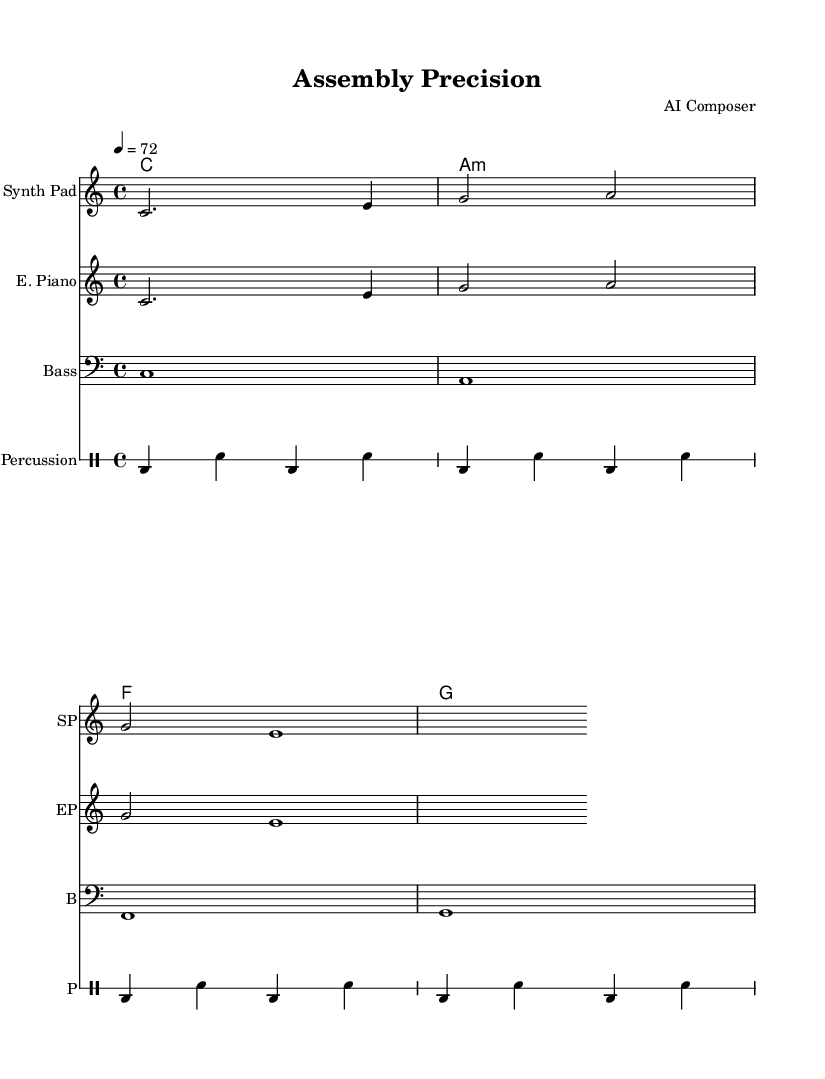What is the key signature of this music? The key signature is C major, which has no sharps or flats.
Answer: C major What is the time signature of this music? The time signature is indicated after the key signature and consists of two numbers, with the top number showing the number of beats in a measure. For this piece, it is 4 over 4, meaning there are four beats per measure.
Answer: 4/4 What is the tempo marking of this music? The tempo marking is shown as a metronome indication at the beginning of the piece, set at 72 BPM, indicating that there are 72 beats played in one minute.
Answer: 72 Which instrument plays the melody? The sheet music indicates the "Synth Pad" and "E. Piano" as instruments. Both have the same melody, so each plays a melodic line. However, the notation shows a designated melody in the staff.
Answer: Synth Pad and E. Piano What are the four harmonic chords used in this piece? The harmonic chords are listed in a specific order in the chord names section, representing the underlying harmony. They are C major, A minor, F major, and G major.
Answer: C, A:min, F, G How many measures does the melody consist of? By counting the measures indicated in the melody section of the sheet music, we find that there are three measures for the melody. The counting process involves tallying the vertical lines indicating the measure divisions.
Answer: 3 What type of percussion pattern is used in this piece? The percussion section shows a repeated pattern of bass drum and snare hits. Each repeated section of four denotes the rhythm and style typical of ambient electronica, providing a steady pulse for focus.
Answer: Bass drum and snare 